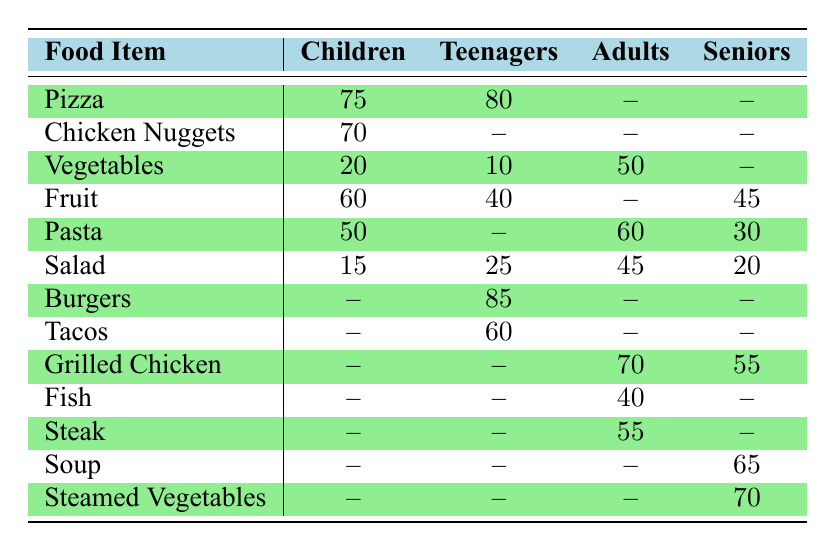What food item has the highest percentage preference among children? Looking at the table, Pizza has a 75% preference, which is the highest among the food items listed for the children age group.
Answer: Pizza Which food item is most preferred by teenagers? From the table, Burgers have the highest preference at 85%, making them the most preferred food item among teenagers.
Answer: Burgers What is the total percentage preference for Fruits among all age groups? The table lists the preferences for Fruits as follows: Children (60), Teenagers (40), Adults (45), and Seniors (45). Summing these percentages gives 60 + 40 + 45 + 45 = 190.
Answer: 190 Is there any food item that has the same preference percentage for both adults and seniors? Looking through the preferences, Grilled Chicken has a value of 55 for adults and also 55 for seniors, confirming that it has the same preference percentage for both groups.
Answer: Yes What percentage of teenagers prefer Tacos? According to the table, 60% of teenagers prefer Tacos.
Answer: 60 What is the average preference percentage for Vegetables across all age groups? The preferences for Vegetables are 20% (children), 10% (teenagers), 50% (adults), and 70% (seniors). To find the average, calculate (20 + 10 + 50 + 70) / 4 = 150 / 4 = 37.5.
Answer: 37.5 Which age group has the lowest preference for Salad? The table shows that Children have the lowest preference for Salad at 15%. By comparing all the age groups' preferences, it's confirmed that Children have the least preference.
Answer: Children What is the difference in preference percentage for Grilled Chicken between seniors and adults? The table shows Grilled Chicken preferences as 55% for seniors and 70% for adults. The difference can be calculated as 70 - 55 = 15.
Answer: 15 If only Pizza and Chicken Nuggets are considered, what is the total preference percentage for these two items among children? The table shows that children prefer Pizza at 75% and Chicken Nuggets at 70%. Adding these percentages gives 75 + 70 = 145.
Answer: 145 Which food item is preferred by seniors but not by adults? From examining the table, Soup (65%) and Steamed Vegetables (70%) are preferred by seniors but are not listed in the preferences for adults, indicating these items are not favored by them.
Answer: Soup and Steamed Vegetables 